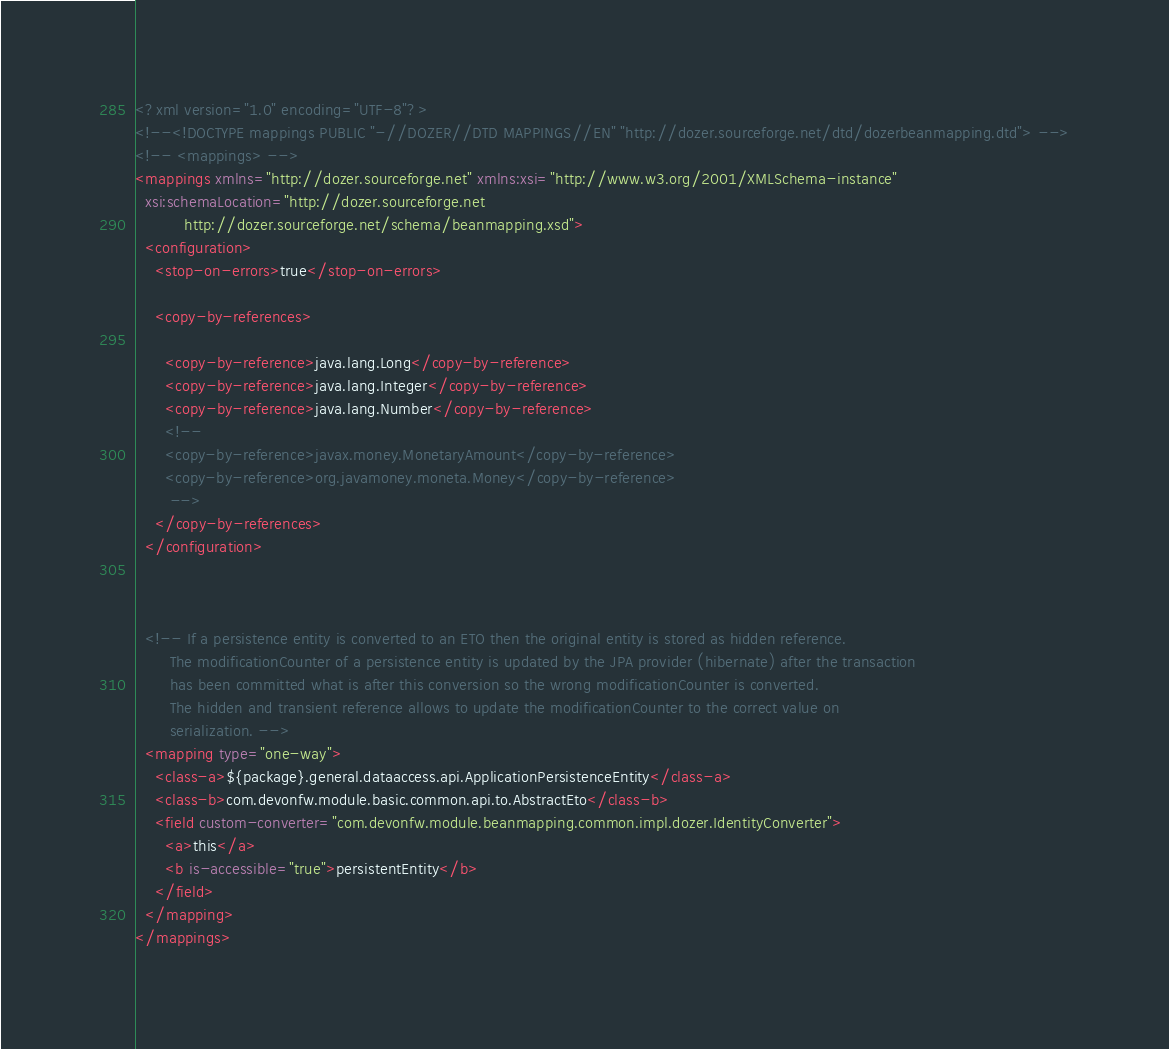<code> <loc_0><loc_0><loc_500><loc_500><_XML_><?xml version="1.0" encoding="UTF-8"?>
<!--<!DOCTYPE mappings PUBLIC "-//DOZER//DTD MAPPINGS//EN" "http://dozer.sourceforge.net/dtd/dozerbeanmapping.dtd"> -->
<!-- <mappings> -->
<mappings xmlns="http://dozer.sourceforge.net" xmlns:xsi="http://www.w3.org/2001/XMLSchema-instance"
  xsi:schemaLocation="http://dozer.sourceforge.net
          http://dozer.sourceforge.net/schema/beanmapping.xsd">
  <configuration>
    <stop-on-errors>true</stop-on-errors>

    <copy-by-references>
      
      <copy-by-reference>java.lang.Long</copy-by-reference>
      <copy-by-reference>java.lang.Integer</copy-by-reference>
      <copy-by-reference>java.lang.Number</copy-by-reference>
      <!--
      <copy-by-reference>javax.money.MonetaryAmount</copy-by-reference>
      <copy-by-reference>org.javamoney.moneta.Money</copy-by-reference>
       -->
    </copy-by-references>
  </configuration>

  

  <!-- If a persistence entity is converted to an ETO then the original entity is stored as hidden reference.
       The modificationCounter of a persistence entity is updated by the JPA provider (hibernate) after the transaction
       has been committed what is after this conversion so the wrong modificationCounter is converted.
       The hidden and transient reference allows to update the modificationCounter to the correct value on
       serialization. -->
  <mapping type="one-way">
    <class-a>${package}.general.dataaccess.api.ApplicationPersistenceEntity</class-a>
    <class-b>com.devonfw.module.basic.common.api.to.AbstractEto</class-b>
    <field custom-converter="com.devonfw.module.beanmapping.common.impl.dozer.IdentityConverter">
      <a>this</a>
      <b is-accessible="true">persistentEntity</b>
    </field>
  </mapping>
</mappings>
</code> 